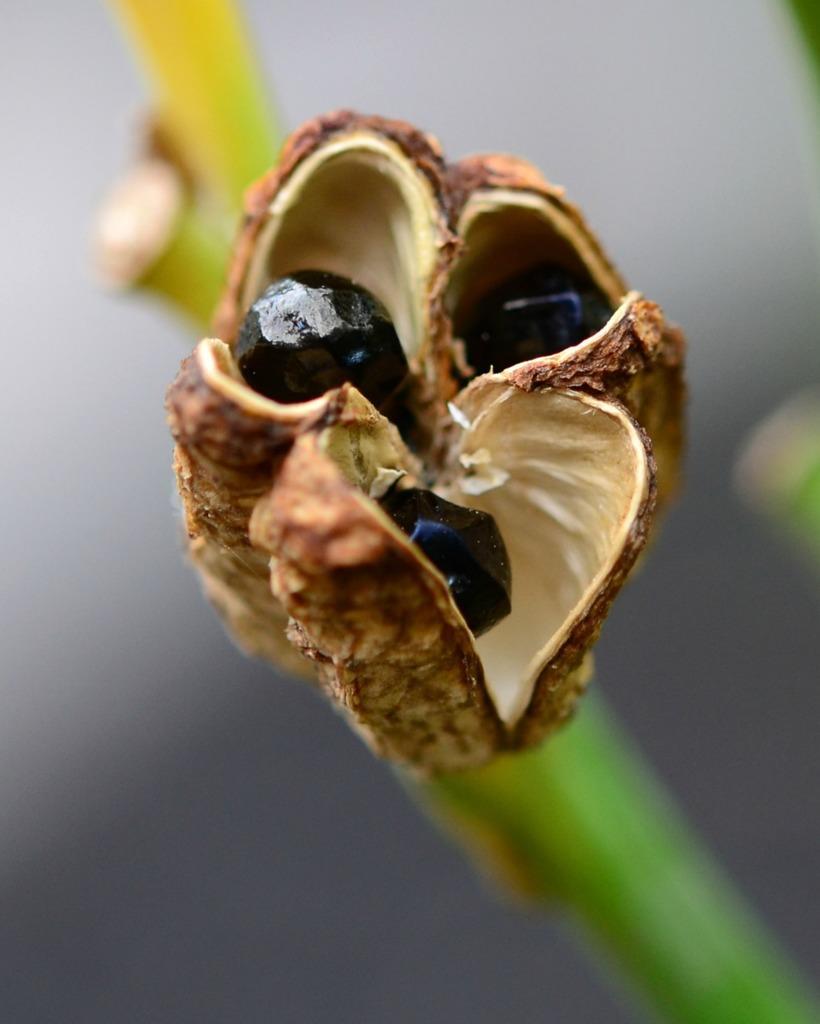Can you describe this image briefly? In the center of the image there is a flower. 